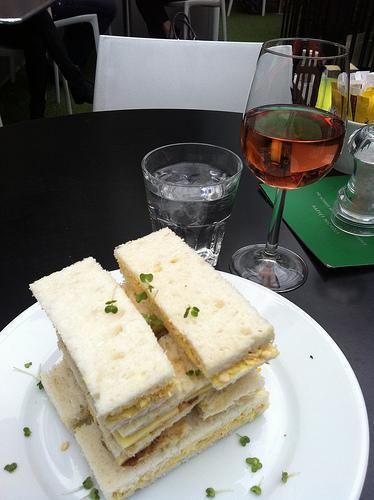How many sandwiches are shown?
Give a very brief answer. 6. 